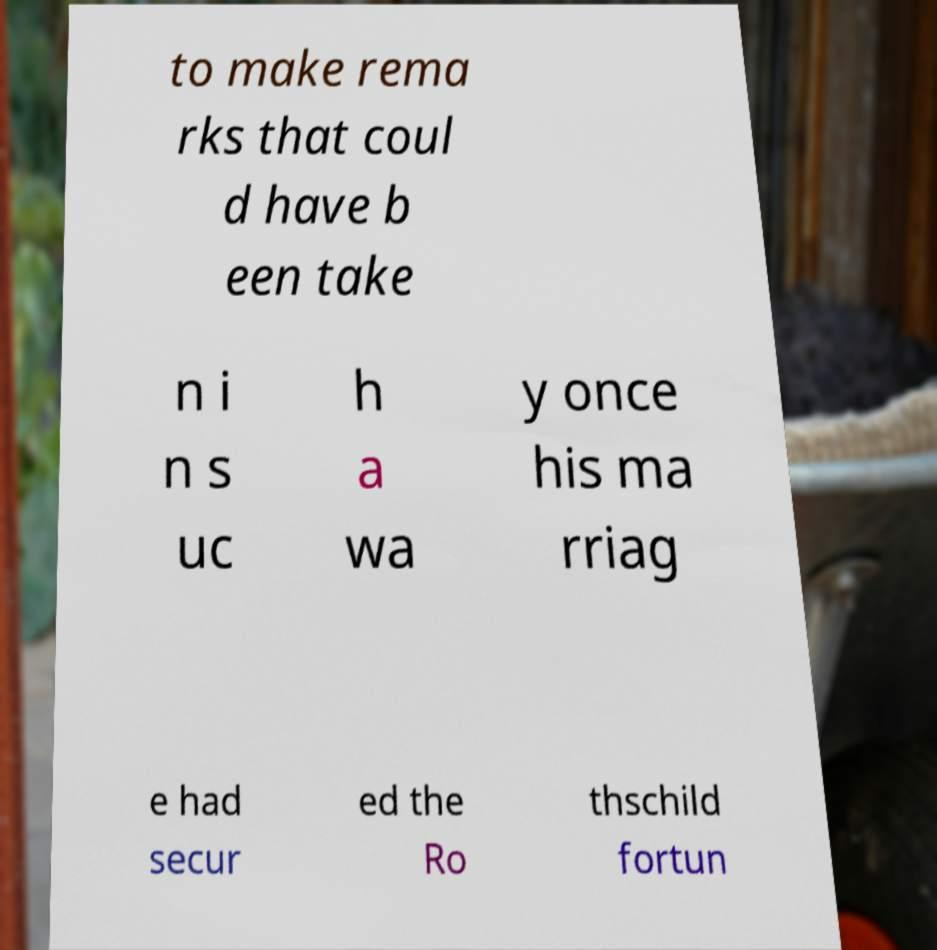Please identify and transcribe the text found in this image. to make rema rks that coul d have b een take n i n s uc h a wa y once his ma rriag e had secur ed the Ro thschild fortun 